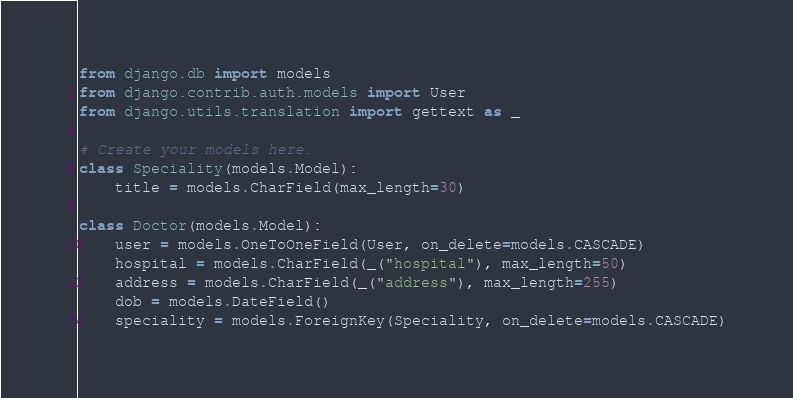Convert code to text. <code><loc_0><loc_0><loc_500><loc_500><_Python_>from django.db import models
from django.contrib.auth.models import User
from django.utils.translation import gettext as _

# Create your models here.
class Speciality(models.Model):
    title = models.CharField(max_length=30)

class Doctor(models.Model):
    user = models.OneToOneField(User, on_delete=models.CASCADE)
    hospital = models.CharField(_("hospital"), max_length=50)
    address = models.CharField(_("address"), max_length=255)
    dob = models.DateField()
    speciality = models.ForeignKey(Speciality, on_delete=models.CASCADE)</code> 